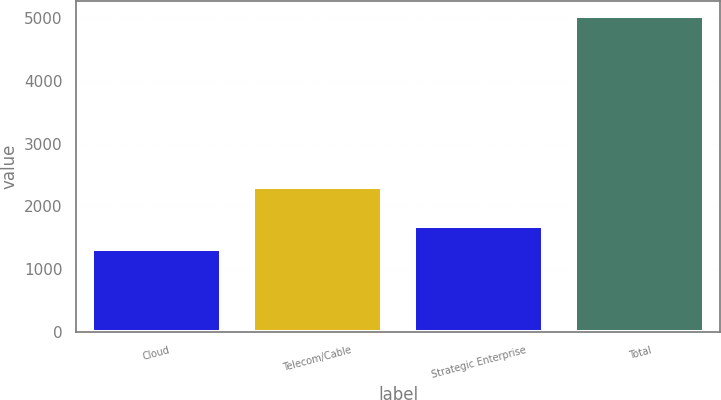Convert chart to OTSL. <chart><loc_0><loc_0><loc_500><loc_500><bar_chart><fcel>Cloud<fcel>Telecom/Cable<fcel>Strategic Enterprise<fcel>Total<nl><fcel>1314.9<fcel>2315.7<fcel>1686.13<fcel>5027.2<nl></chart> 